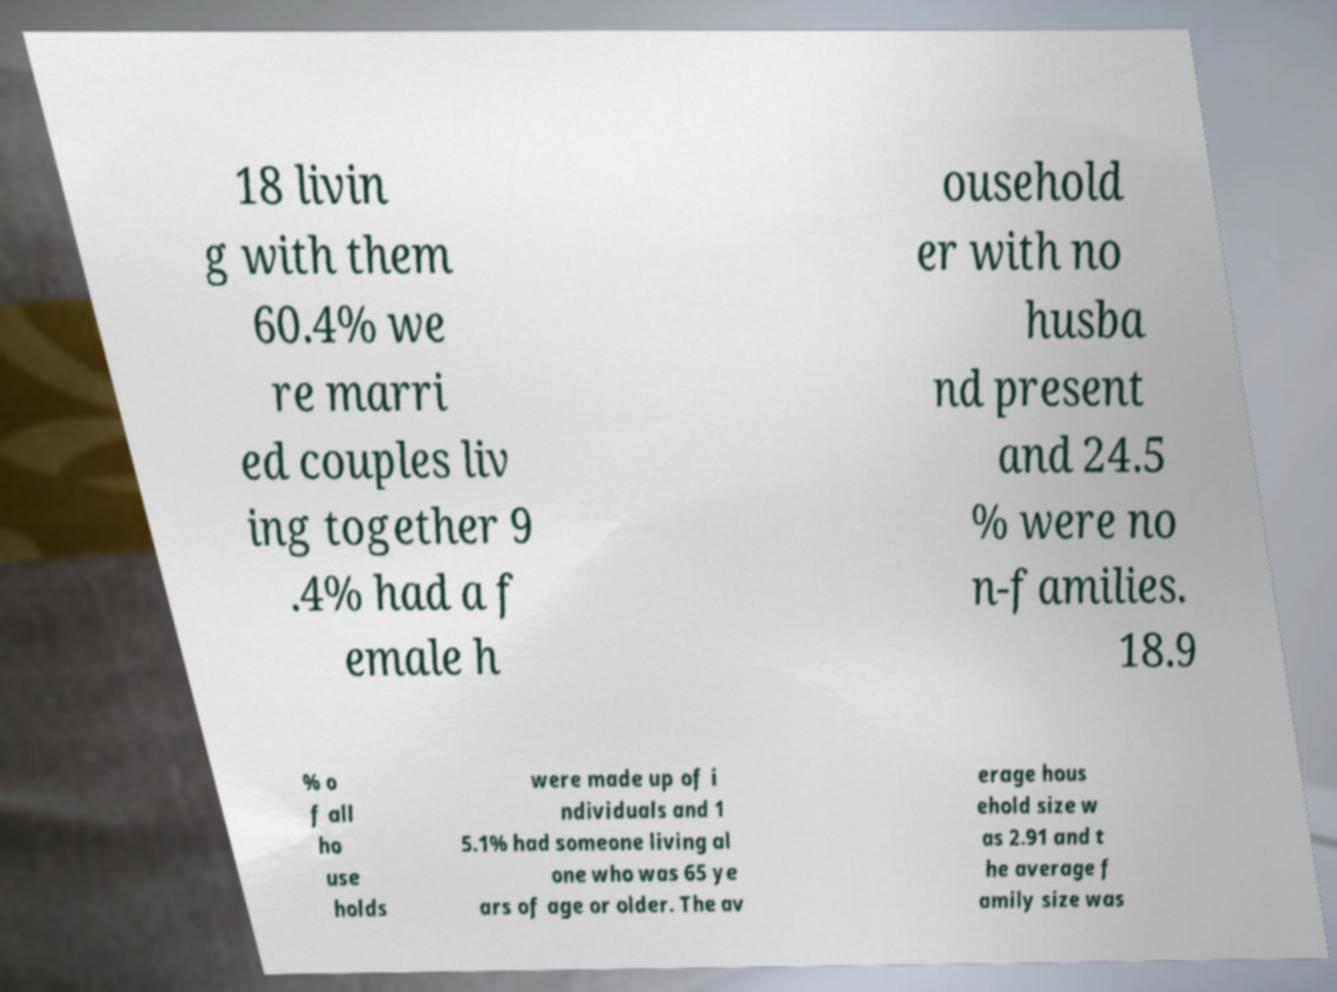Can you read and provide the text displayed in the image?This photo seems to have some interesting text. Can you extract and type it out for me? 18 livin g with them 60.4% we re marri ed couples liv ing together 9 .4% had a f emale h ousehold er with no husba nd present and 24.5 % were no n-families. 18.9 % o f all ho use holds were made up of i ndividuals and 1 5.1% had someone living al one who was 65 ye ars of age or older. The av erage hous ehold size w as 2.91 and t he average f amily size was 